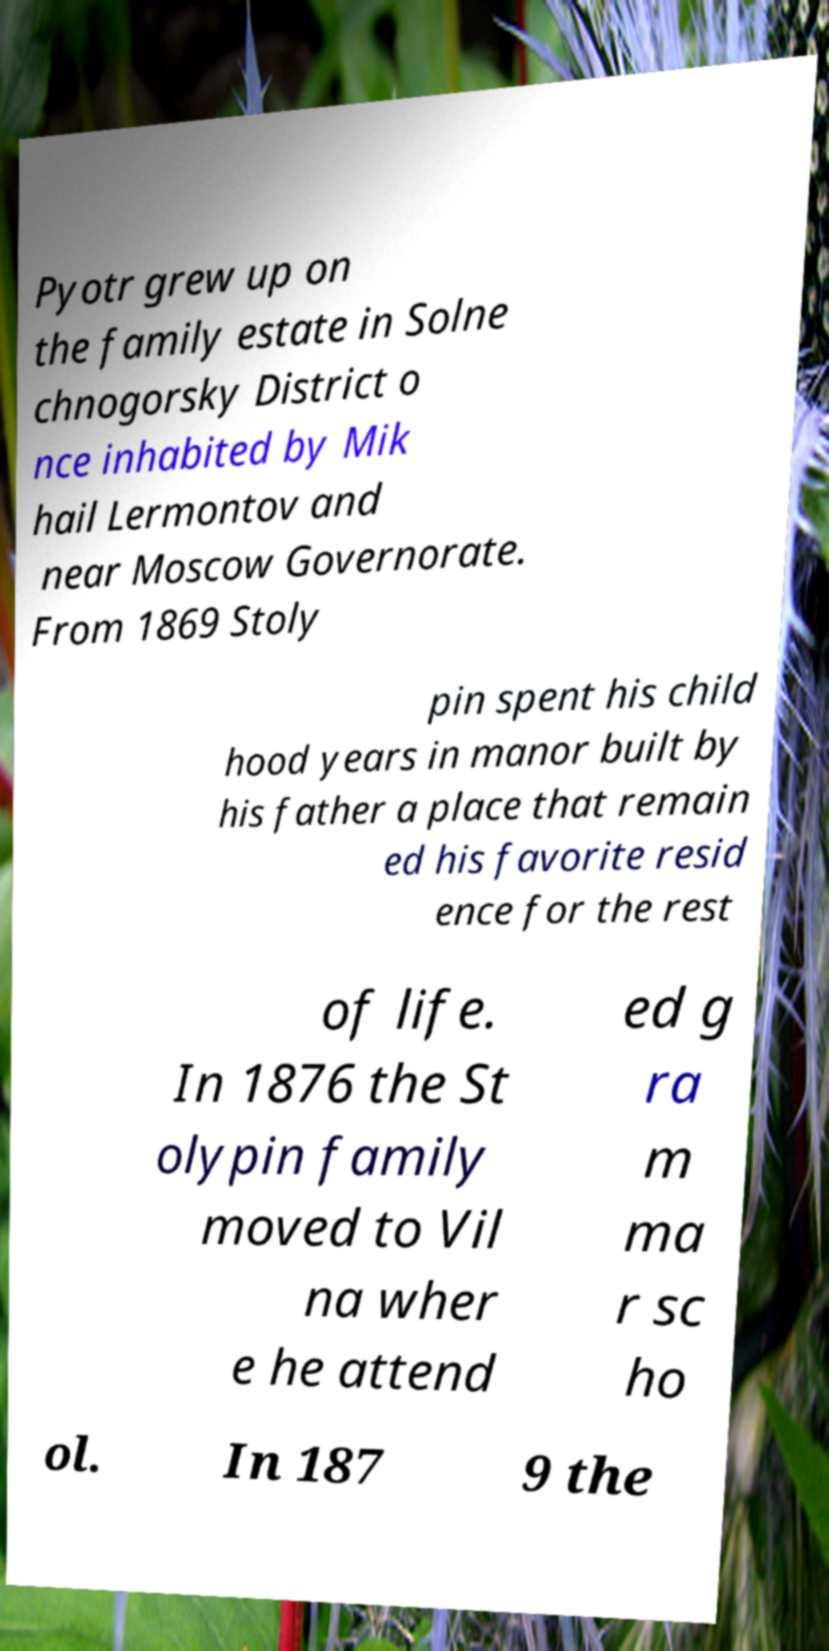What messages or text are displayed in this image? I need them in a readable, typed format. Pyotr grew up on the family estate in Solne chnogorsky District o nce inhabited by Mik hail Lermontov and near Moscow Governorate. From 1869 Stoly pin spent his child hood years in manor built by his father a place that remain ed his favorite resid ence for the rest of life. In 1876 the St olypin family moved to Vil na wher e he attend ed g ra m ma r sc ho ol. In 187 9 the 